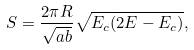Convert formula to latex. <formula><loc_0><loc_0><loc_500><loc_500>S = \frac { 2 \pi R } { \sqrt { a b } } \sqrt { E _ { c } ( 2 E - E _ { c } ) } ,</formula> 